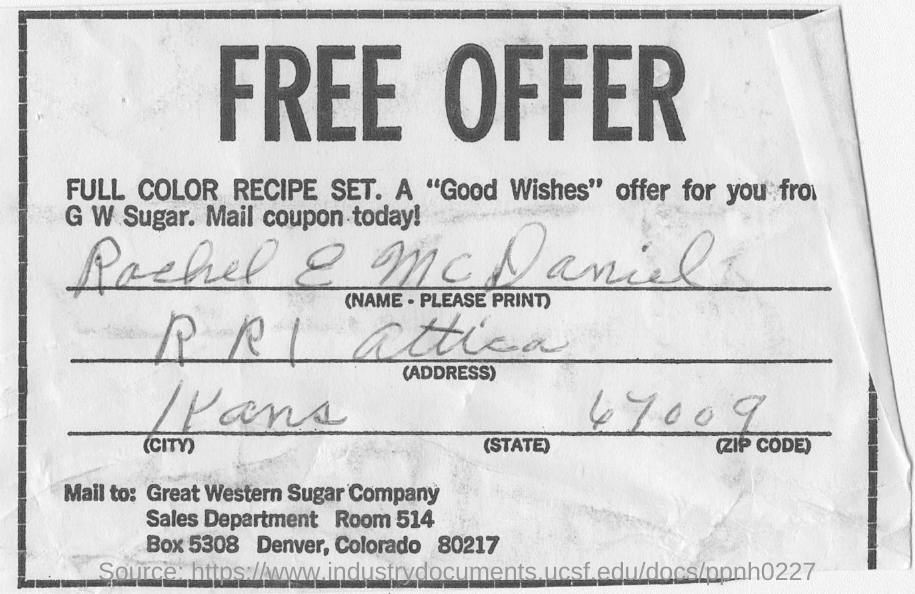Who is the "Good Wishes" offer from?
Your answer should be very brief. G W Sugar. What is the zip code handwritten on the form?
Offer a terse response. 67009. Who filled this form?
Offer a terse response. RACHEL E MCDANIEL. 